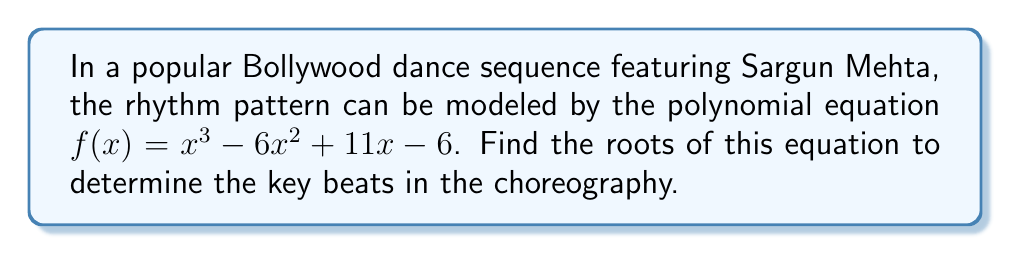Could you help me with this problem? To find the roots of the polynomial equation $f(x) = x^3 - 6x^2 + 11x - 6$, we need to factor the equation and solve for x when $f(x) = 0$.

Step 1: Let's start by trying to guess one of the factors. Since the constant term is -6, possible factors could be ±1, ±2, ±3, or ±6. By trial and error or using the rational root theorem, we can find that (x - 1) is a factor.

Step 2: Divide the polynomial by (x - 1) using polynomial long division:

$$ \frac{x^3 - 6x^2 + 11x - 6}{x - 1} = x^2 - 5x + 6 $$

Step 3: The polynomial can now be written as:

$$ f(x) = (x - 1)(x^2 - 5x + 6) $$

Step 4: Factor the quadratic term $(x^2 - 5x + 6)$:

$$ x^2 - 5x + 6 = (x - 2)(x - 3) $$

Step 5: The fully factored polynomial is:

$$ f(x) = (x - 1)(x - 2)(x - 3) $$

Step 6: Set each factor to zero and solve for x:

$x - 1 = 0 \implies x = 1$
$x - 2 = 0 \implies x = 2$
$x - 3 = 0 \implies x = 3$

Therefore, the roots of the equation are 1, 2, and 3.
Answer: The roots of the polynomial equation $f(x) = x^3 - 6x^2 + 11x - 6$ are $x = 1$, $x = 2$, and $x = 3$. 